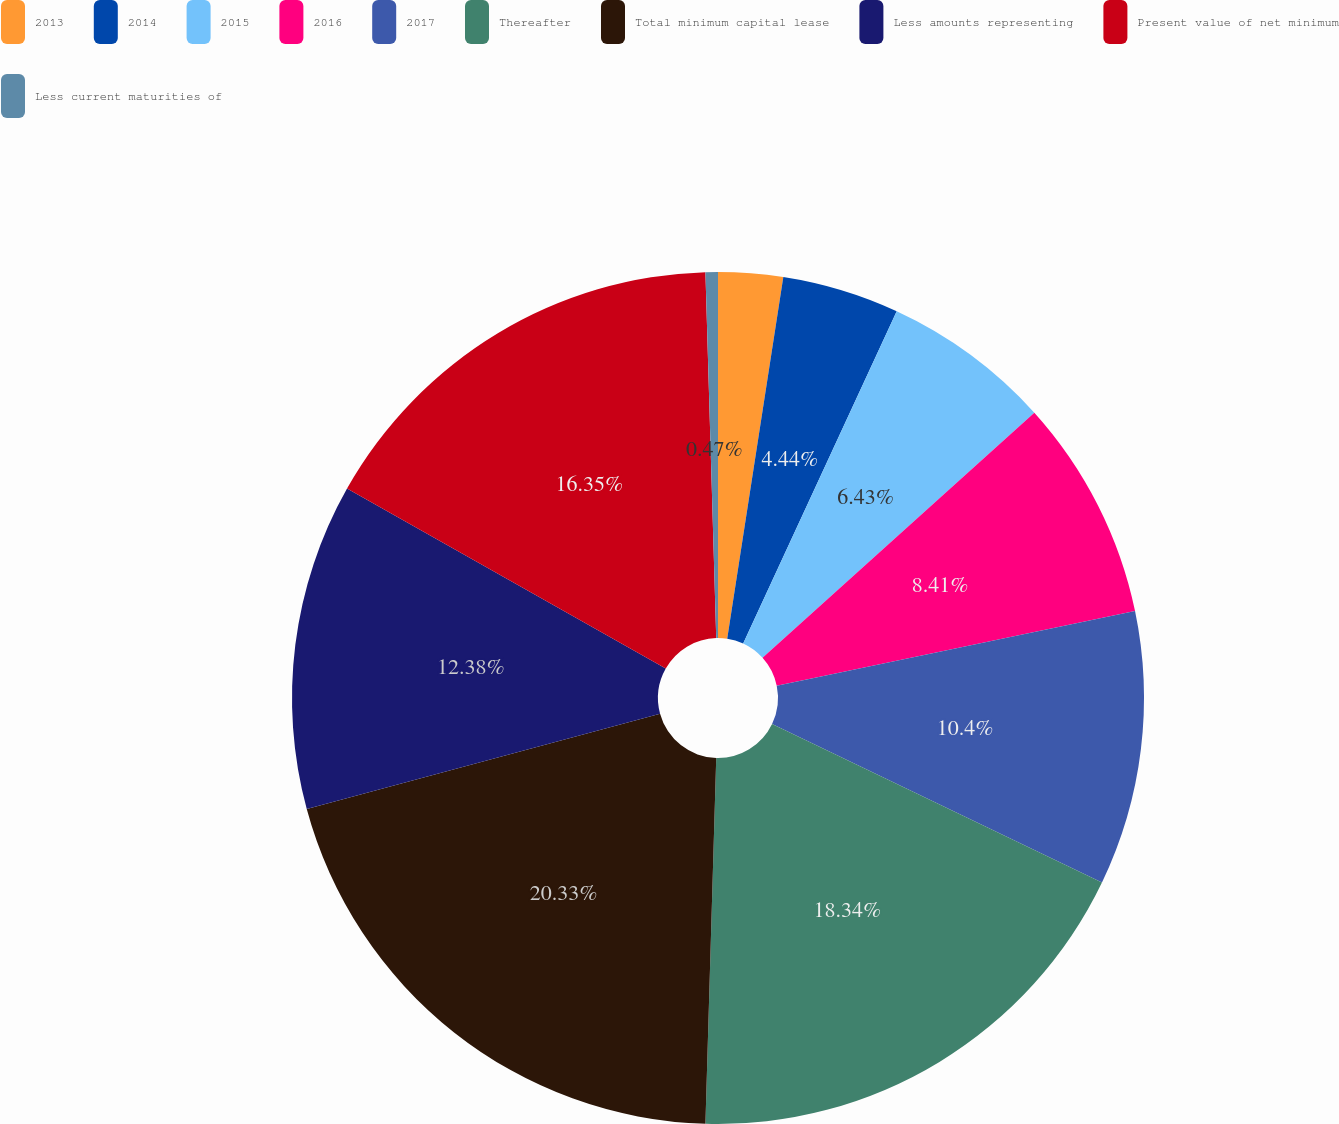Convert chart. <chart><loc_0><loc_0><loc_500><loc_500><pie_chart><fcel>2013<fcel>2014<fcel>2015<fcel>2016<fcel>2017<fcel>Thereafter<fcel>Total minimum capital lease<fcel>Less amounts representing<fcel>Present value of net minimum<fcel>Less current maturities of<nl><fcel>2.45%<fcel>4.44%<fcel>6.43%<fcel>8.41%<fcel>10.4%<fcel>18.34%<fcel>20.33%<fcel>12.38%<fcel>16.35%<fcel>0.47%<nl></chart> 